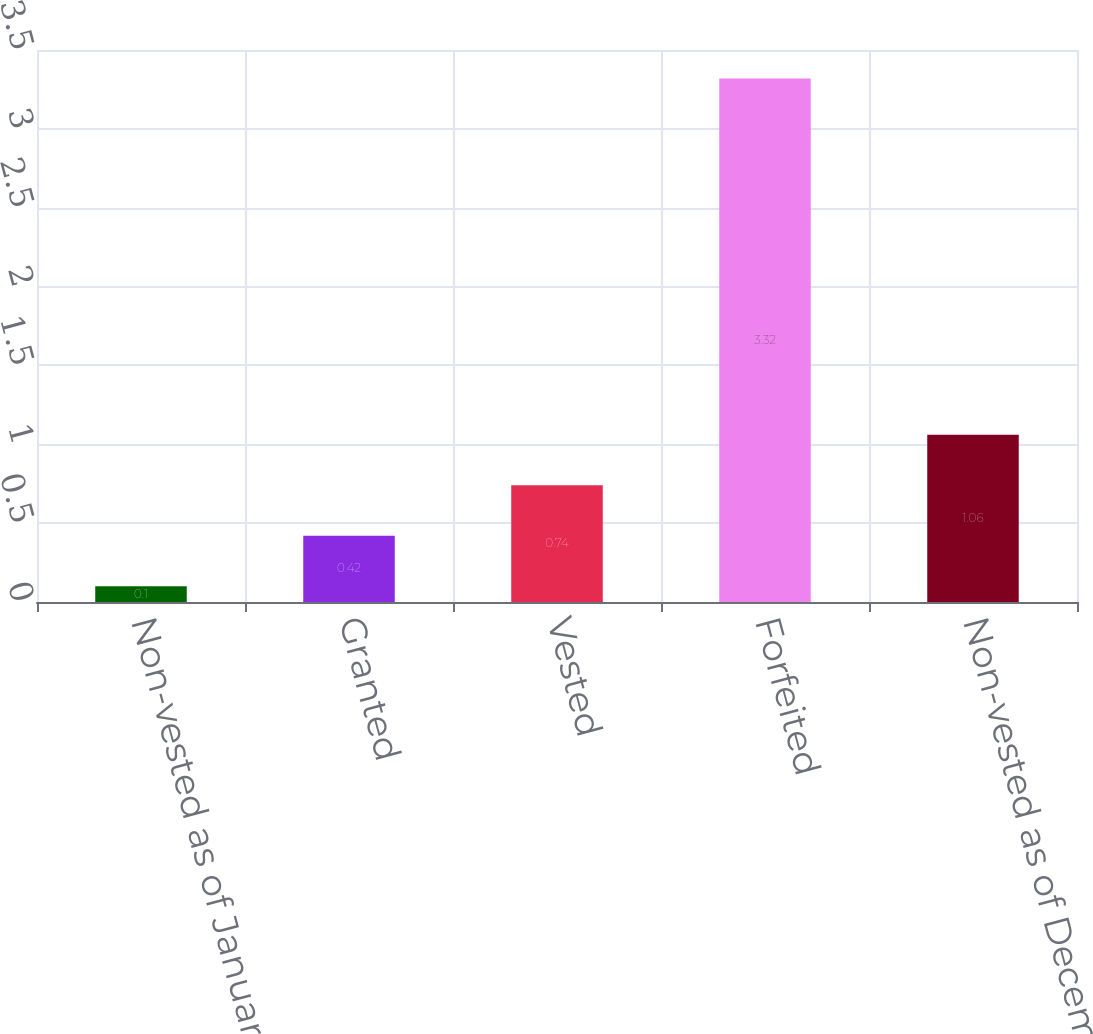<chart> <loc_0><loc_0><loc_500><loc_500><bar_chart><fcel>Non-vested as of January 1<fcel>Granted<fcel>Vested<fcel>Forfeited<fcel>Non-vested as of December 31<nl><fcel>0.1<fcel>0.42<fcel>0.74<fcel>3.32<fcel>1.06<nl></chart> 